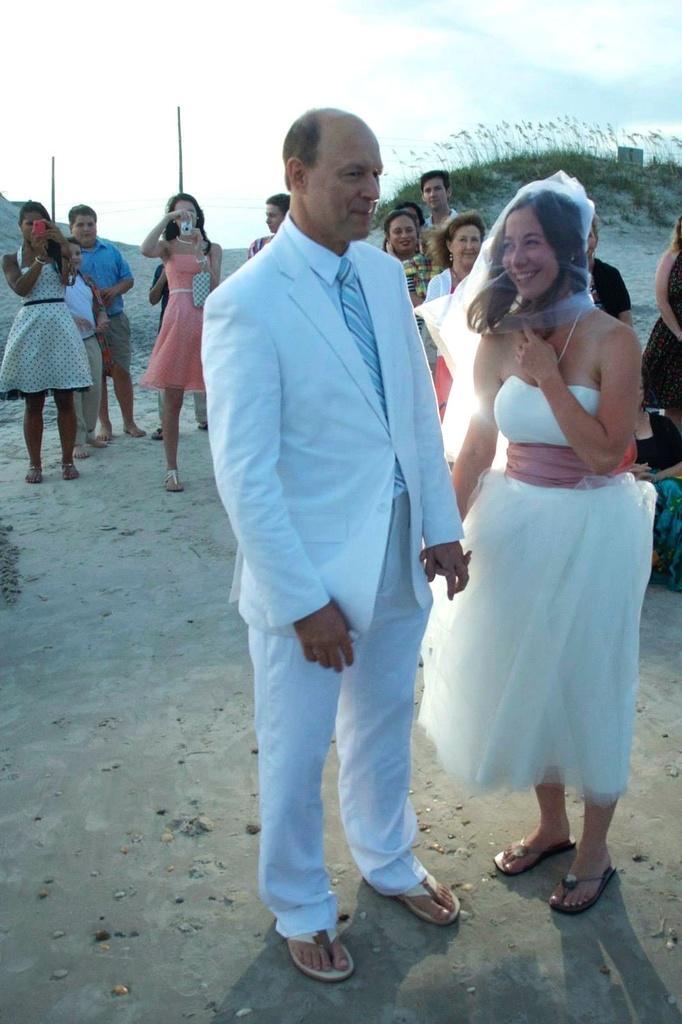Could you give a brief overview of what you see in this image? In this image there is a man and a woman standing with a smile on their face, behind them there are a few other people standing and clicking pictures. 